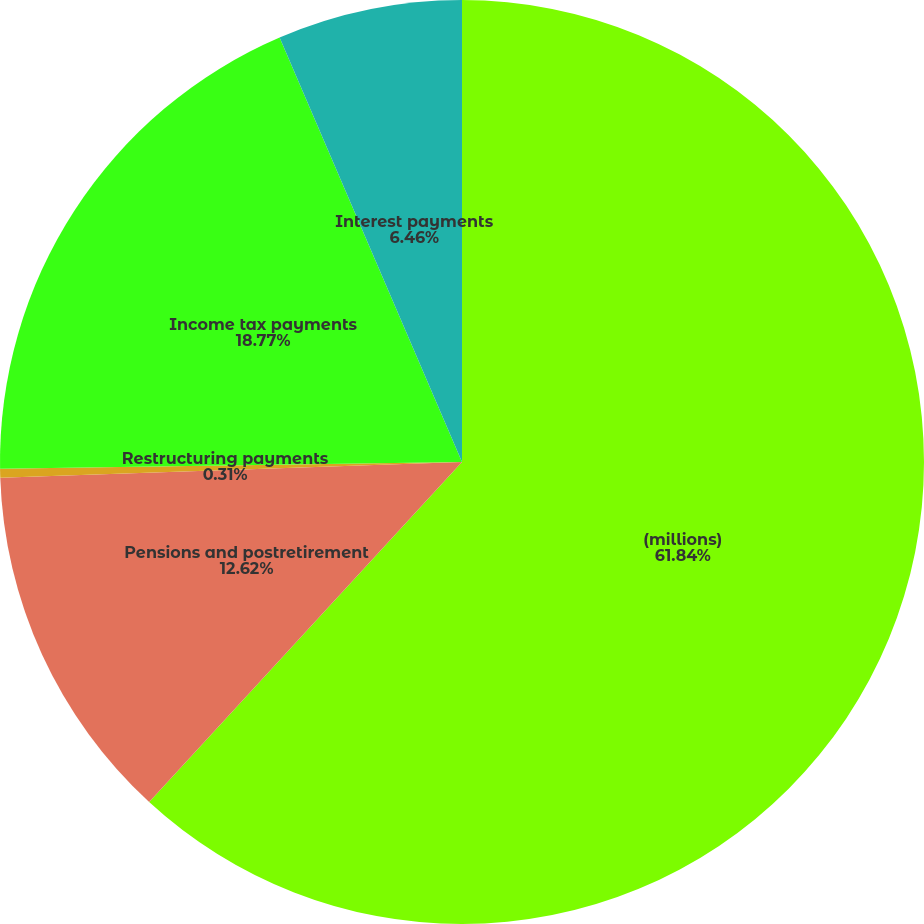Convert chart. <chart><loc_0><loc_0><loc_500><loc_500><pie_chart><fcel>(millions)<fcel>Pensions and postretirement<fcel>Restructuring payments<fcel>Income tax payments<fcel>Interest payments<nl><fcel>61.84%<fcel>12.62%<fcel>0.31%<fcel>18.77%<fcel>6.46%<nl></chart> 